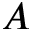<formula> <loc_0><loc_0><loc_500><loc_500>A</formula> 